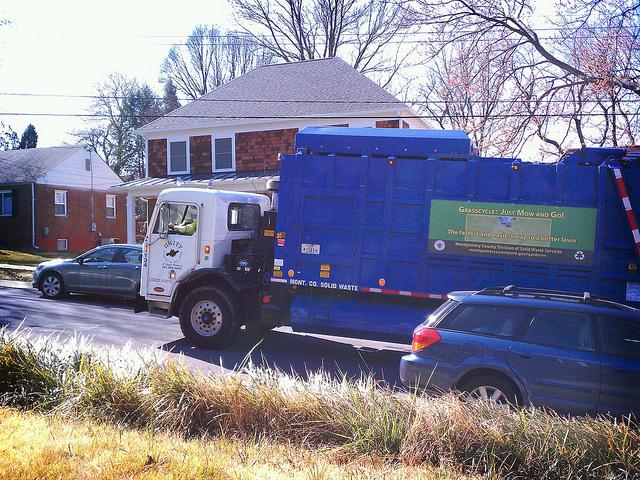How many trucks are there?
Concise answer only. 1. What kind of truck is pictured?
Be succinct. Garbage. What season is this?
Short answer required. Fall. 